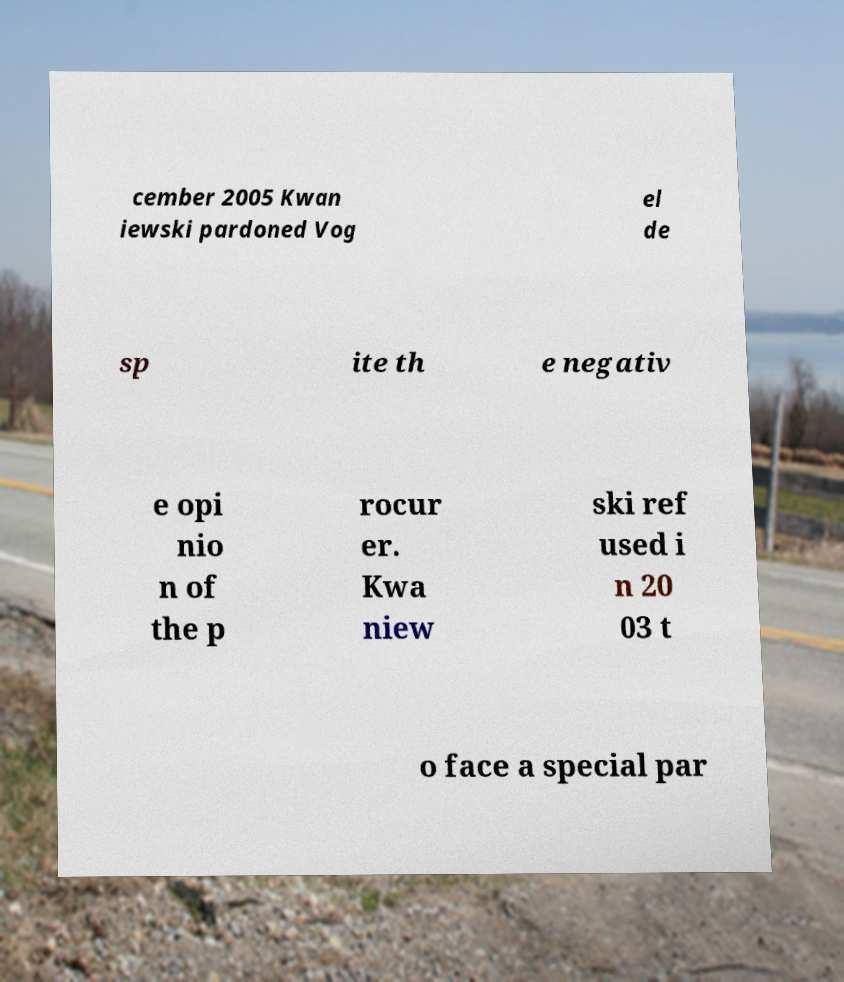Could you extract and type out the text from this image? cember 2005 Kwan iewski pardoned Vog el de sp ite th e negativ e opi nio n of the p rocur er. Kwa niew ski ref used i n 20 03 t o face a special par 